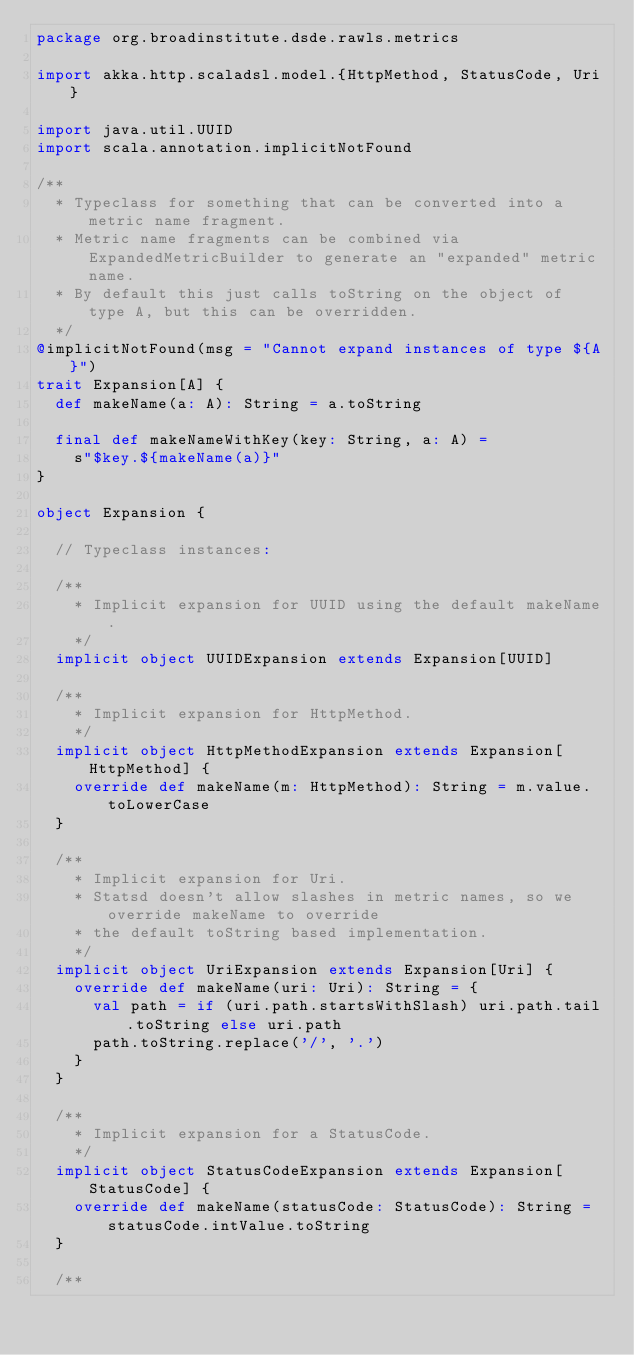Convert code to text. <code><loc_0><loc_0><loc_500><loc_500><_Scala_>package org.broadinstitute.dsde.rawls.metrics

import akka.http.scaladsl.model.{HttpMethod, StatusCode, Uri}

import java.util.UUID
import scala.annotation.implicitNotFound

/**
  * Typeclass for something that can be converted into a metric name fragment.
  * Metric name fragments can be combined via ExpandedMetricBuilder to generate an "expanded" metric name.
  * By default this just calls toString on the object of type A, but this can be overridden.
  */
@implicitNotFound(msg = "Cannot expand instances of type ${A}")
trait Expansion[A] {
  def makeName(a: A): String = a.toString

  final def makeNameWithKey(key: String, a: A) =
    s"$key.${makeName(a)}"
}

object Expansion {

  // Typeclass instances:

  /**
    * Implicit expansion for UUID using the default makeName.
    */
  implicit object UUIDExpansion extends Expansion[UUID]

  /**
    * Implicit expansion for HttpMethod.
    */
  implicit object HttpMethodExpansion extends Expansion[HttpMethod] {
    override def makeName(m: HttpMethod): String = m.value.toLowerCase
  }

  /**
    * Implicit expansion for Uri.
    * Statsd doesn't allow slashes in metric names, so we override makeName to override
    * the default toString based implementation.
    */
  implicit object UriExpansion extends Expansion[Uri] {
    override def makeName(uri: Uri): String = {
      val path = if (uri.path.startsWithSlash) uri.path.tail.toString else uri.path
      path.toString.replace('/', '.')
    }
  }

  /**
    * Implicit expansion for a StatusCode.
    */
  implicit object StatusCodeExpansion extends Expansion[StatusCode] {
    override def makeName(statusCode: StatusCode): String = statusCode.intValue.toString
  }

  /**</code> 